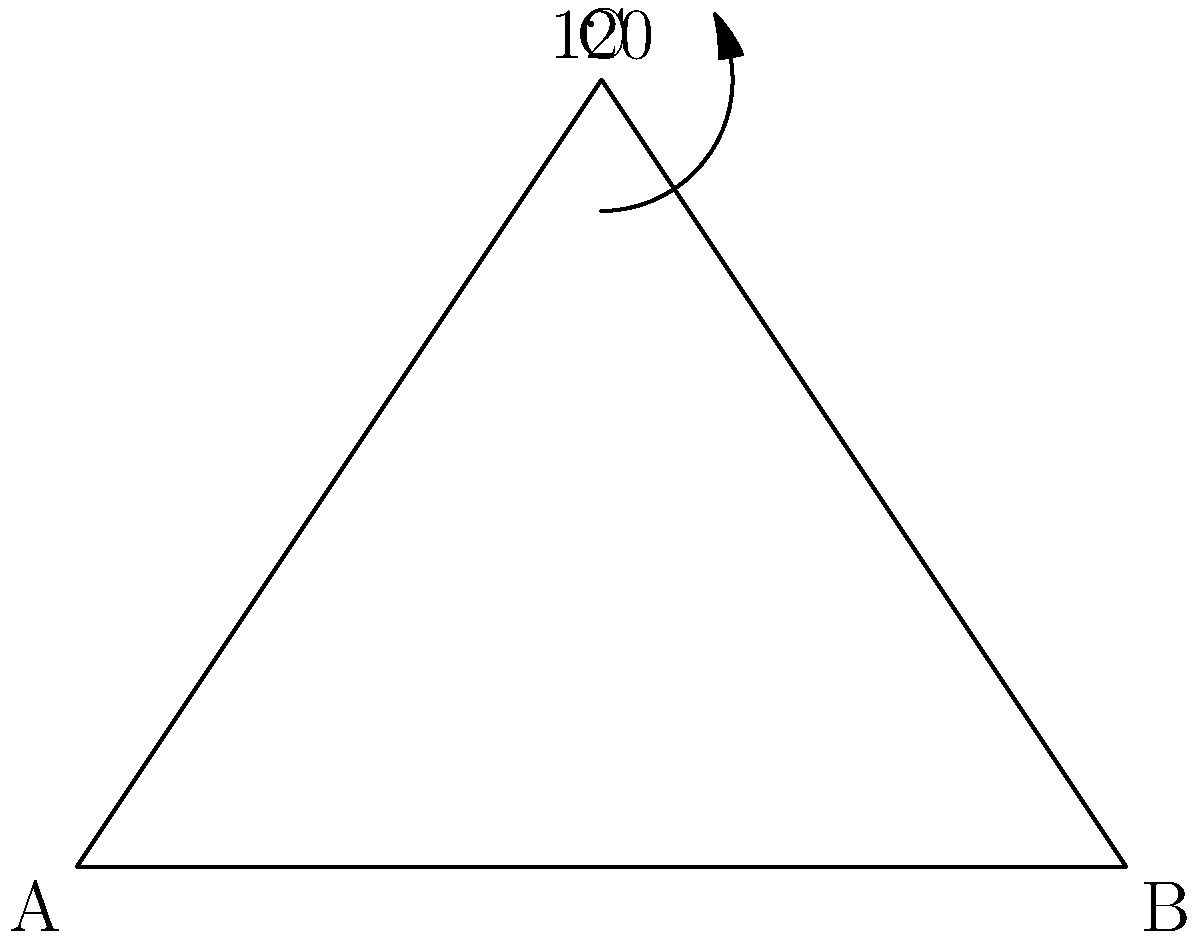As you open a hardcover book from the mobile library, you notice that the angle formed by the spine is 120°. If the book's front cover is represented by line AC and the back cover by line BC in the diagram, what is the measure of angle CAB? Let's approach this step-by-step:

1) In the triangle ABC, we're given that angle ACB is 120°.

2) We know that the sum of angles in a triangle is always 180°.

3) Let's call the angle CAB as x° and angle CBA as y°.

4) We can write an equation:
   $x° + y° + 120° = 180°$

5) In an isosceles triangle, the angles opposite the equal sides are equal. Since the covers of a book are typically the same length, we can assume AC = BC, making this an isosceles triangle.

6) Therefore, $x° = y°$

7) Substituting this into our equation:
   $x° + x° + 120° = 180°$
   $2x° + 120° = 180°$

8) Solving for x:
   $2x° = 60°$
   $x° = 30°$

Therefore, the measure of angle CAB is 30°.
Answer: 30° 